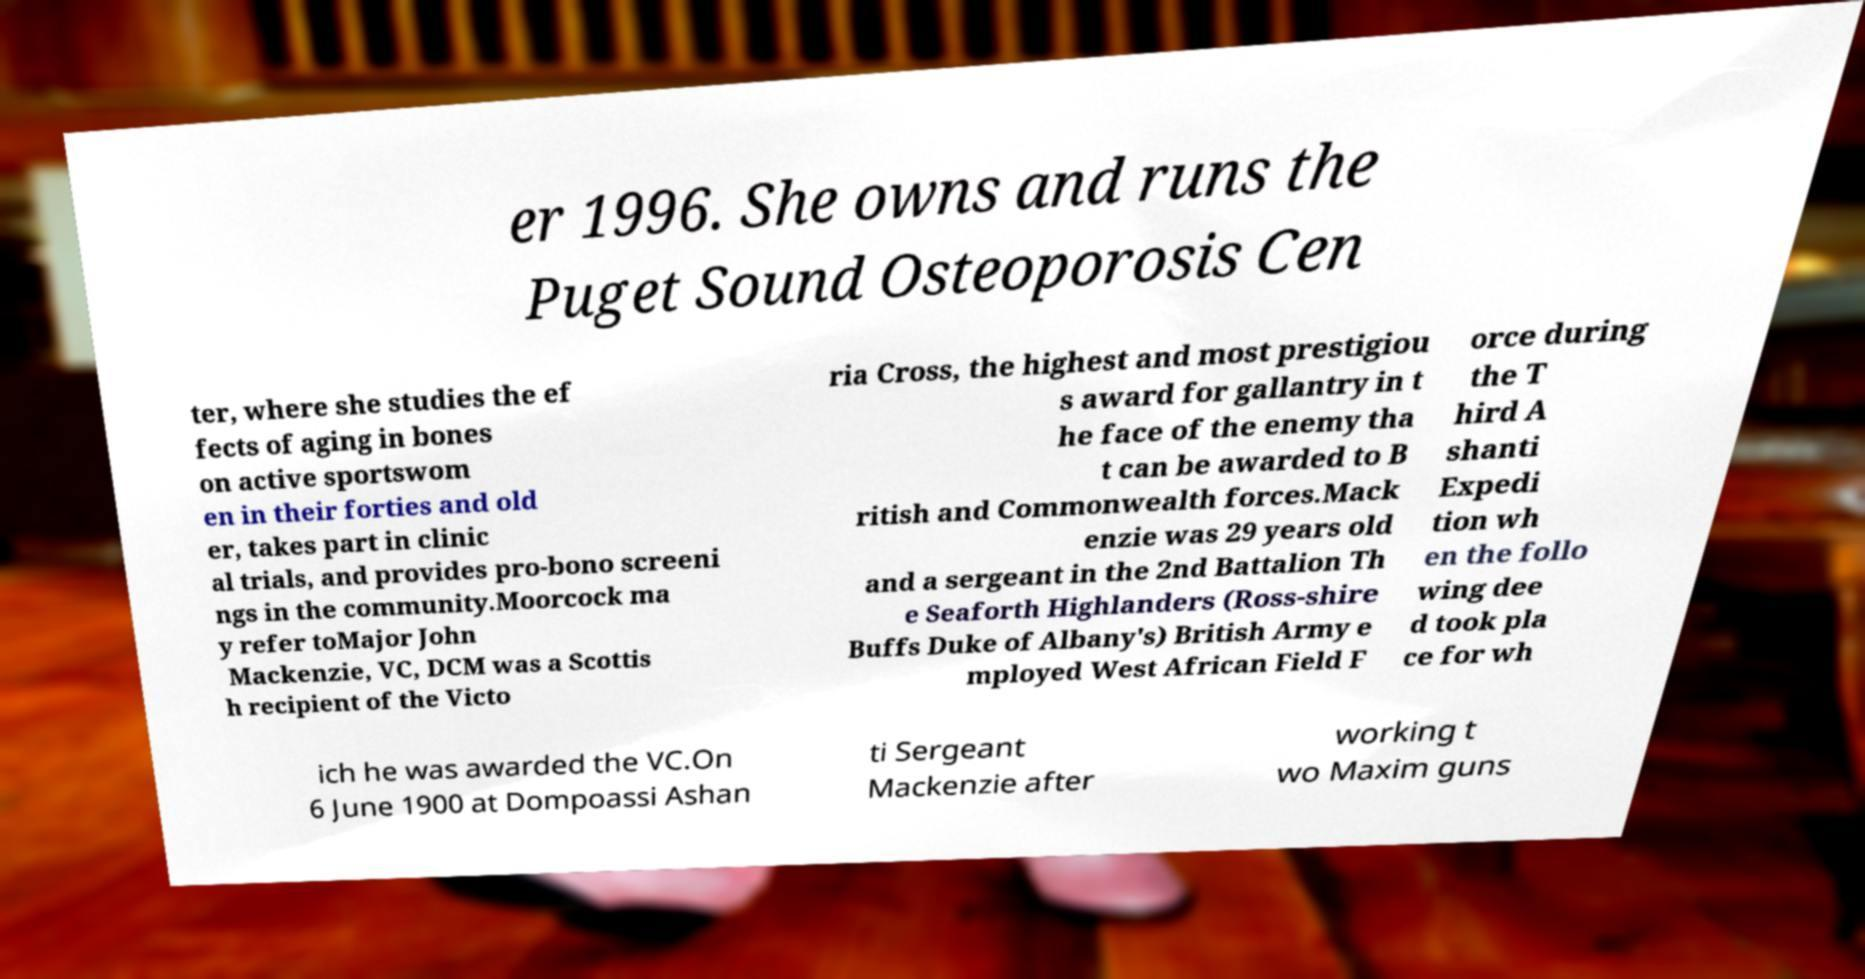I need the written content from this picture converted into text. Can you do that? er 1996. She owns and runs the Puget Sound Osteoporosis Cen ter, where she studies the ef fects of aging in bones on active sportswom en in their forties and old er, takes part in clinic al trials, and provides pro-bono screeni ngs in the community.Moorcock ma y refer toMajor John Mackenzie, VC, DCM was a Scottis h recipient of the Victo ria Cross, the highest and most prestigiou s award for gallantry in t he face of the enemy tha t can be awarded to B ritish and Commonwealth forces.Mack enzie was 29 years old and a sergeant in the 2nd Battalion Th e Seaforth Highlanders (Ross-shire Buffs Duke of Albany's) British Army e mployed West African Field F orce during the T hird A shanti Expedi tion wh en the follo wing dee d took pla ce for wh ich he was awarded the VC.On 6 June 1900 at Dompoassi Ashan ti Sergeant Mackenzie after working t wo Maxim guns 